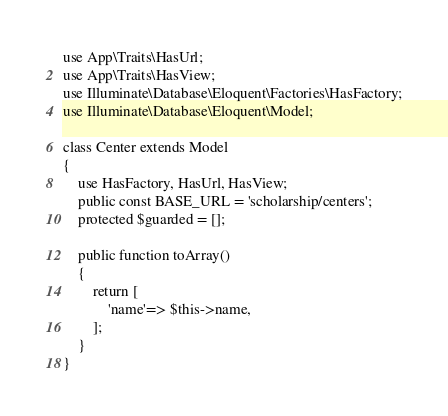Convert code to text. <code><loc_0><loc_0><loc_500><loc_500><_PHP_>
use App\Traits\HasUrl;
use App\Traits\HasView;
use Illuminate\Database\Eloquent\Factories\HasFactory;
use Illuminate\Database\Eloquent\Model;

class Center extends Model
{
    use HasFactory, HasUrl, HasView;
    public const BASE_URL = 'scholarship/centers';
    protected $guarded = [];

    public function toArray()
    {
        return [
            'name'=> $this->name,
        ];
    }
}
</code> 